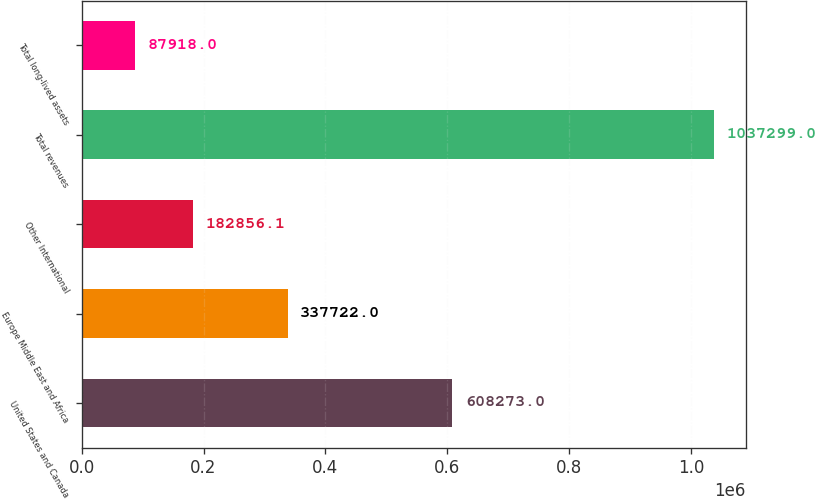Convert chart. <chart><loc_0><loc_0><loc_500><loc_500><bar_chart><fcel>United States and Canada<fcel>Europe Middle East and Africa<fcel>Other International<fcel>Total revenues<fcel>Total long-lived assets<nl><fcel>608273<fcel>337722<fcel>182856<fcel>1.0373e+06<fcel>87918<nl></chart> 